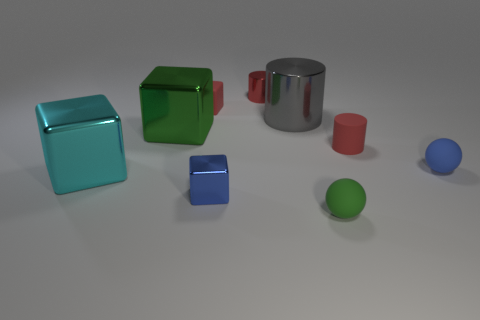Subtract all purple blocks. Subtract all blue cylinders. How many blocks are left? 4 Subtract all blocks. How many objects are left? 5 Add 9 purple cubes. How many purple cubes exist? 9 Subtract 0 cyan cylinders. How many objects are left? 9 Subtract all big gray cylinders. Subtract all big yellow rubber cylinders. How many objects are left? 8 Add 5 small red shiny objects. How many small red shiny objects are left? 6 